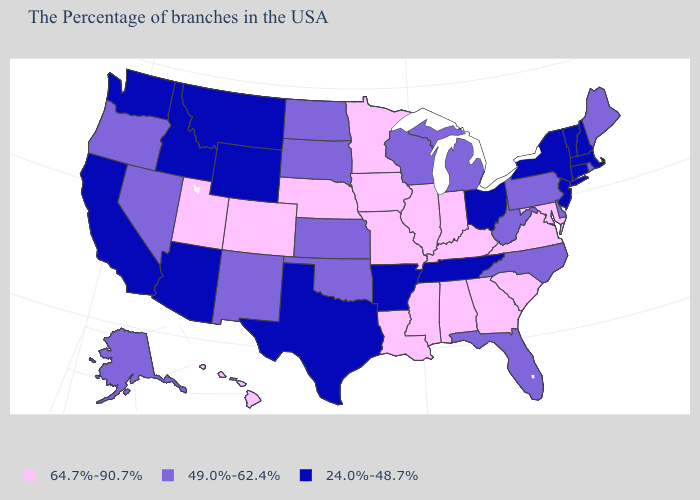Name the states that have a value in the range 24.0%-48.7%?
Concise answer only. Massachusetts, New Hampshire, Vermont, Connecticut, New York, New Jersey, Ohio, Tennessee, Arkansas, Texas, Wyoming, Montana, Arizona, Idaho, California, Washington. Name the states that have a value in the range 24.0%-48.7%?
Answer briefly. Massachusetts, New Hampshire, Vermont, Connecticut, New York, New Jersey, Ohio, Tennessee, Arkansas, Texas, Wyoming, Montana, Arizona, Idaho, California, Washington. What is the value of Pennsylvania?
Short answer required. 49.0%-62.4%. How many symbols are there in the legend?
Write a very short answer. 3. Does Vermont have the lowest value in the Northeast?
Write a very short answer. Yes. Which states have the lowest value in the West?
Quick response, please. Wyoming, Montana, Arizona, Idaho, California, Washington. Does Vermont have the lowest value in the USA?
Concise answer only. Yes. What is the value of Vermont?
Concise answer only. 24.0%-48.7%. What is the highest value in the USA?
Give a very brief answer. 64.7%-90.7%. What is the highest value in the USA?
Concise answer only. 64.7%-90.7%. Does Oregon have the lowest value in the West?
Write a very short answer. No. Name the states that have a value in the range 49.0%-62.4%?
Give a very brief answer. Maine, Rhode Island, Delaware, Pennsylvania, North Carolina, West Virginia, Florida, Michigan, Wisconsin, Kansas, Oklahoma, South Dakota, North Dakota, New Mexico, Nevada, Oregon, Alaska. Name the states that have a value in the range 24.0%-48.7%?
Answer briefly. Massachusetts, New Hampshire, Vermont, Connecticut, New York, New Jersey, Ohio, Tennessee, Arkansas, Texas, Wyoming, Montana, Arizona, Idaho, California, Washington. Does South Dakota have the highest value in the USA?
Concise answer only. No. 